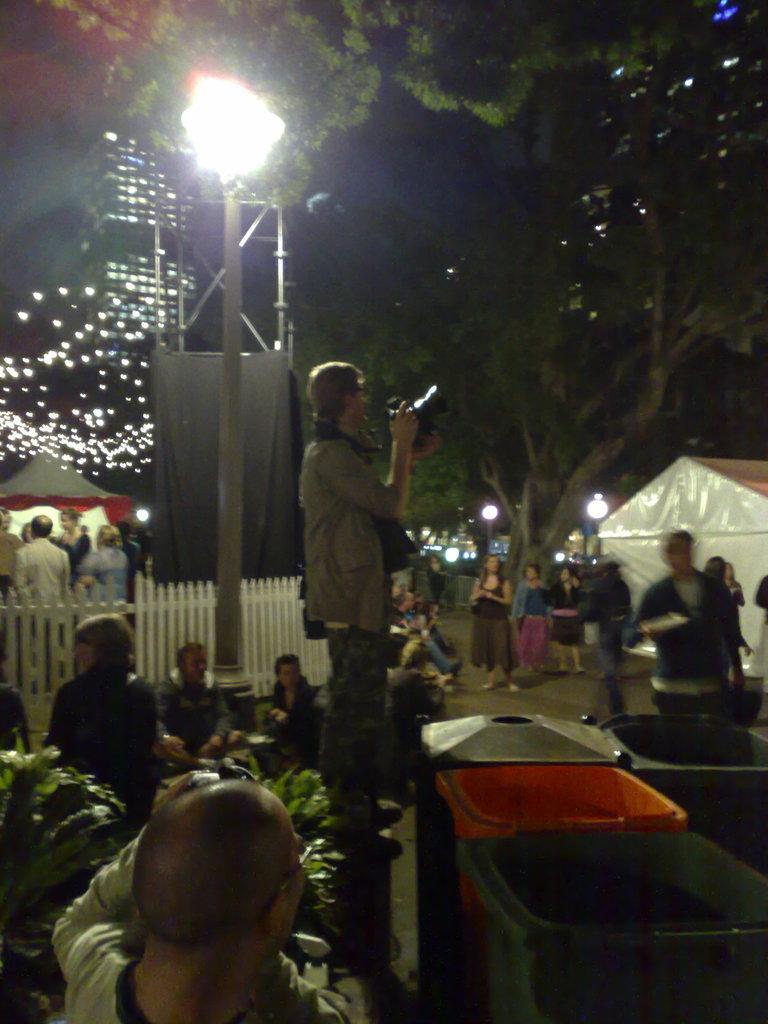Describe this image in one or two sentences. This picture is clicked outside. In the foreground there is a person and there are some boxes placed on the ground and we can see the plants. In the center there is a person holding a black color object and standing on the ground and we can see a white color fence and the group of people. In the background there is a sky, focusing lights, decoration lights and trees and a tent. 